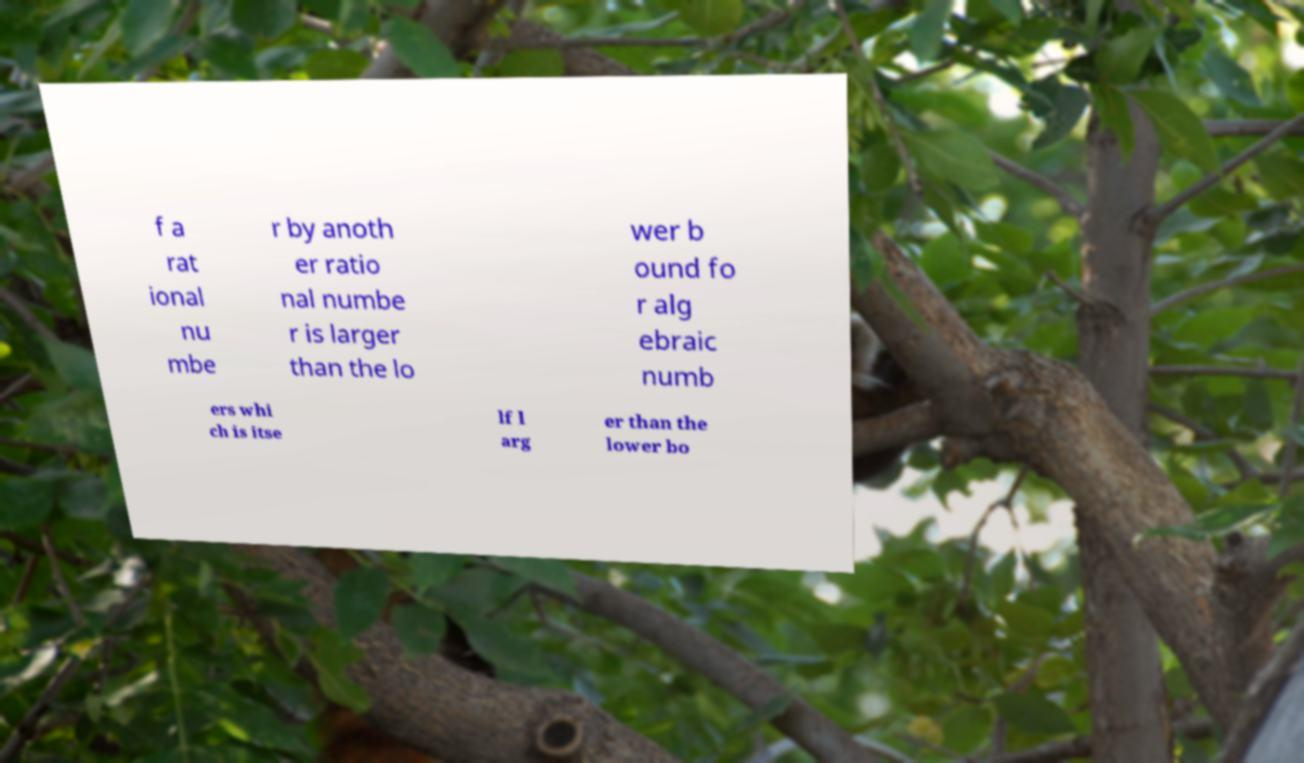Can you read and provide the text displayed in the image?This photo seems to have some interesting text. Can you extract and type it out for me? f a rat ional nu mbe r by anoth er ratio nal numbe r is larger than the lo wer b ound fo r alg ebraic numb ers whi ch is itse lf l arg er than the lower bo 